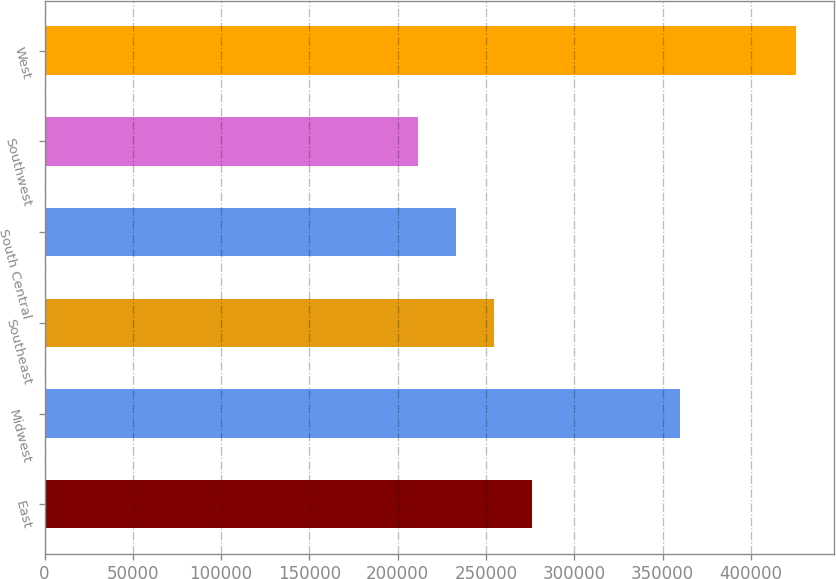Convert chart to OTSL. <chart><loc_0><loc_0><loc_500><loc_500><bar_chart><fcel>East<fcel>Midwest<fcel>Southeast<fcel>South Central<fcel>Southwest<fcel>West<nl><fcel>275860<fcel>359900<fcel>254440<fcel>233020<fcel>211600<fcel>425800<nl></chart> 